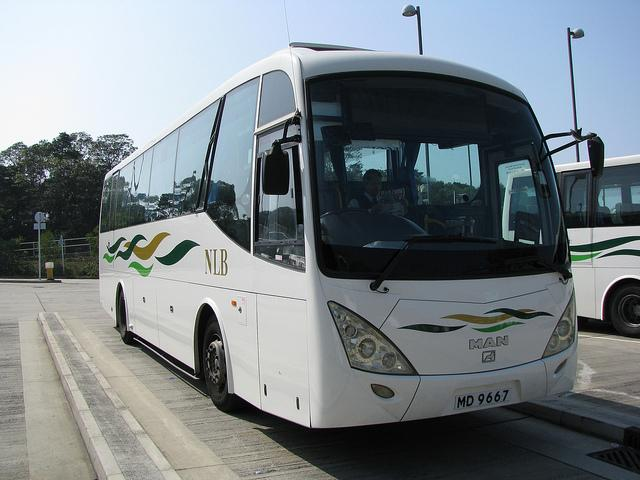What country does this bus originate from? hong kong 